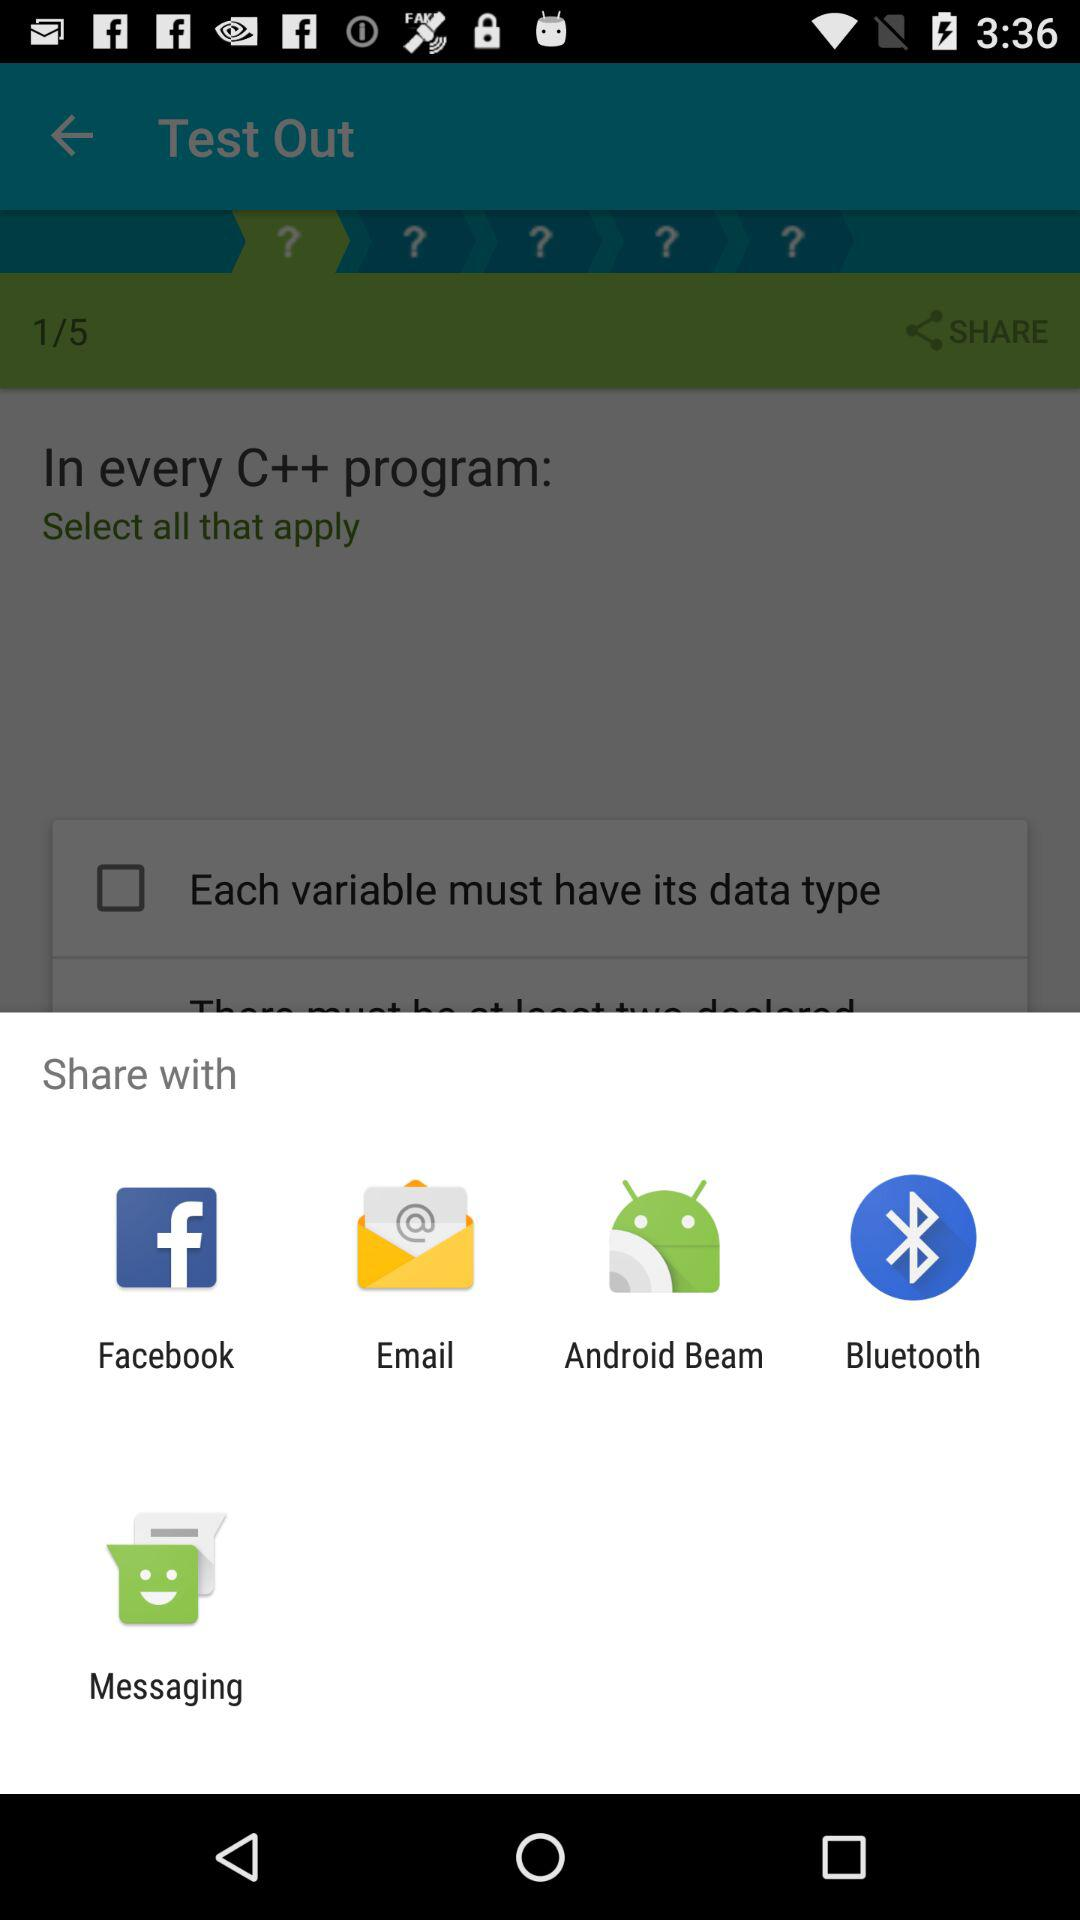With what app can we share it? The apps are "Facebook", "Email", "Android Beam", "Bluetooth", and "Messaging". 